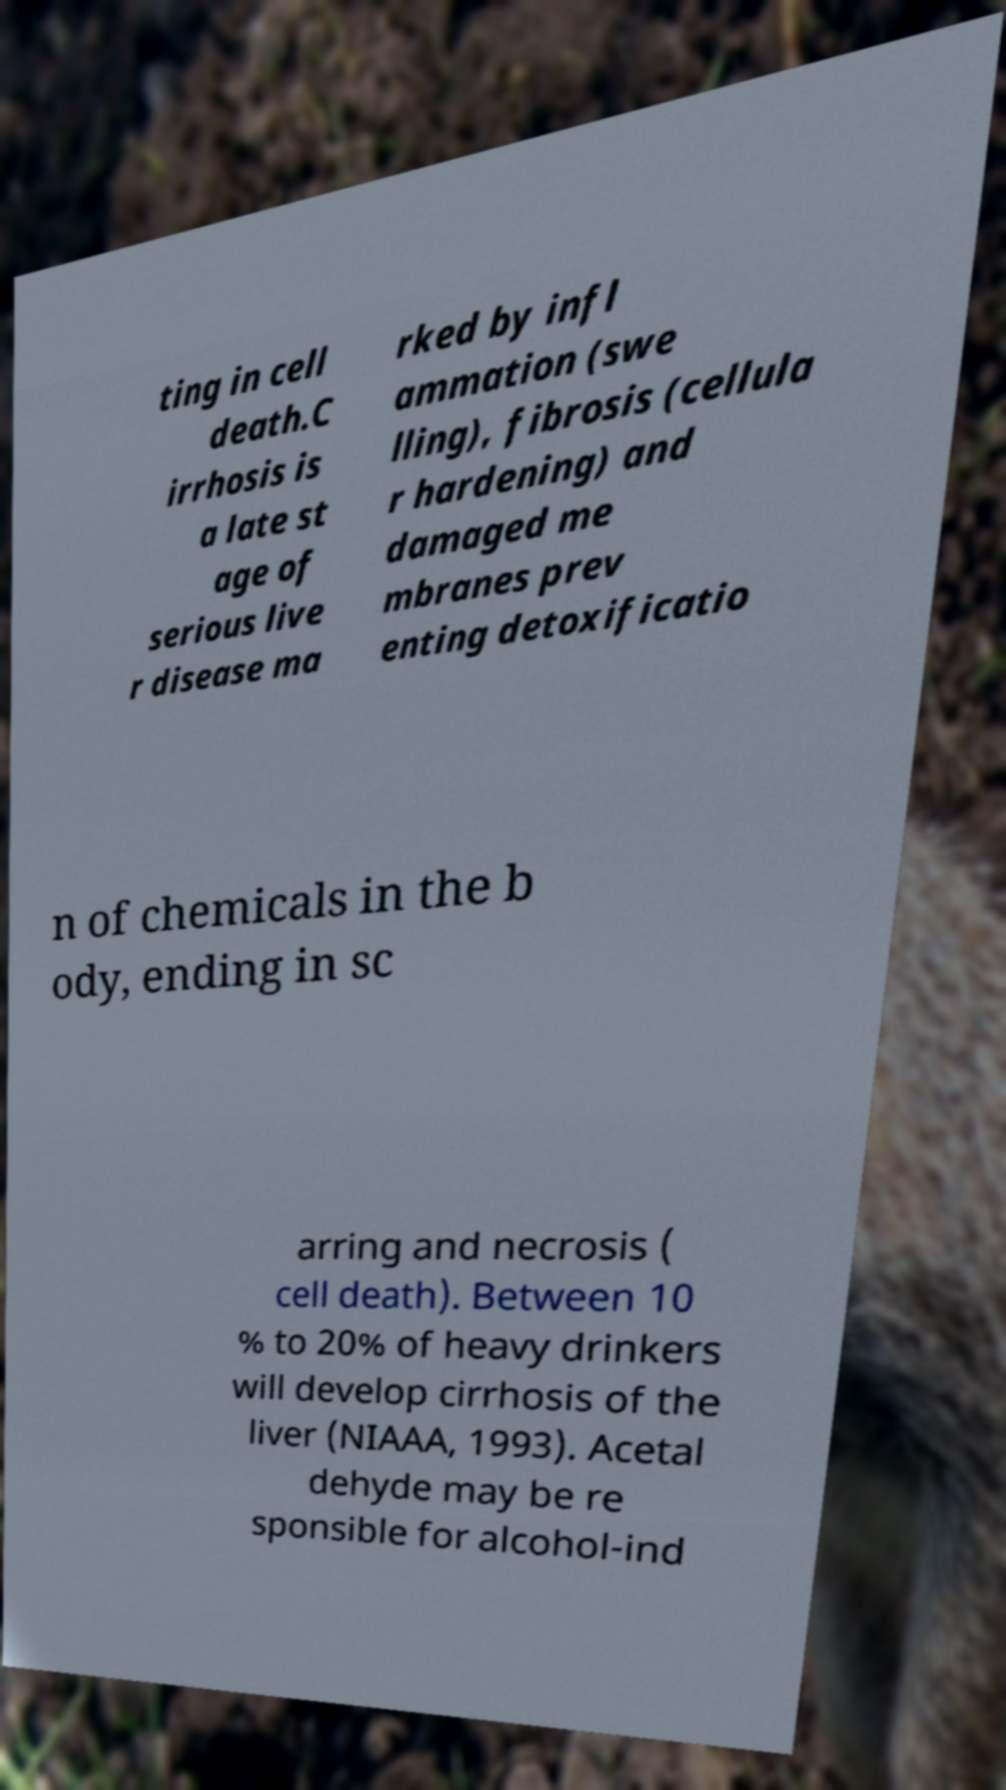Please identify and transcribe the text found in this image. ting in cell death.C irrhosis is a late st age of serious live r disease ma rked by infl ammation (swe lling), fibrosis (cellula r hardening) and damaged me mbranes prev enting detoxificatio n of chemicals in the b ody, ending in sc arring and necrosis ( cell death). Between 10 % to 20% of heavy drinkers will develop cirrhosis of the liver (NIAAA, 1993). Acetal dehyde may be re sponsible for alcohol-ind 